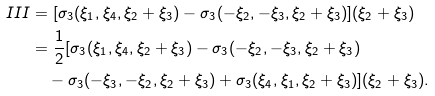Convert formula to latex. <formula><loc_0><loc_0><loc_500><loc_500>I I I = & \ [ \sigma _ { 3 } ( \xi _ { 1 } , \xi _ { 4 } , \xi _ { 2 } + \xi _ { 3 } ) - \sigma _ { 3 } ( - \xi _ { 2 } , - \xi _ { 3 } , \xi _ { 2 } + \xi _ { 3 } ) ] ( \xi _ { 2 } + \xi _ { 3 } ) \\ = & \ \frac { 1 } { 2 } [ \sigma _ { 3 } ( \xi _ { 1 } , \xi _ { 4 } , \xi _ { 2 } + \xi _ { 3 } ) - \sigma _ { 3 } ( - \xi _ { 2 } , - \xi _ { 3 } , \xi _ { 2 } + \xi _ { 3 } ) \\ & - \sigma _ { 3 } ( - \xi _ { 3 } , - \xi _ { 2 } , \xi _ { 2 } + \xi _ { 3 } ) + \sigma _ { 3 } ( \xi _ { 4 } , \xi _ { 1 } , \xi _ { 2 } + \xi _ { 3 } ) ] ( \xi _ { 2 } + \xi _ { 3 } ) .</formula> 